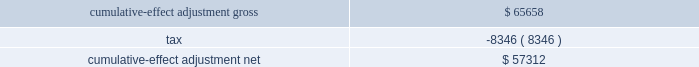Other-than-temporary impairments on investment securities .
In april 2009 , the fasb revised the authoritative guidance for the recognition and presentation of other-than-temporary impairments .
This new guidance amends the recognition guidance for other-than-temporary impairments of debt securities and expands the financial statement disclosures for other-than-temporary impairments on debt and equity securities .
For available for sale debt securities that the company has no intent to sell and more likely than not will not be required to sell prior to recovery , only the credit loss component of the impairment would be recognized in earnings , while the rest of the fair value loss would be recognized in accumulated other comprehensive income ( loss ) .
The company adopted this guidance effective april 1 , 2009 .
Upon adoption the company recognized a cumulative-effect adjustment increase in retained earnings ( deficit ) and decrease in accumulated other comprehensive income ( loss ) as follows : ( dollars in thousands ) .
Measurement of fair value in inactive markets .
In april 2009 , the fasb revised the authoritative guidance for fair value measurements and disclosures , which reaffirms that fair value is the price that would be received to sell an asset or paid to transfer a liability in an orderly transaction between market participants at the measurement date under current market conditions .
It also reaffirms the need to use judgment in determining if a formerly active market has become inactive and in determining fair values when the market has become inactive .
There was no impact to the company 2019s financial statements upon adoption .
Fair value disclosures about pension plan assets .
In december 2008 , the fasb revised the authoritative guidance for employers 2019 disclosures about pension plan assets .
This new guidance requires additional disclosures about the components of plan assets , investment strategies for plan assets and significant concentrations of risk within plan assets .
The company , in conjunction with fair value measurement of plan assets , separated plan assets into the three fair value hierarchy levels and provided a roll forward of the changes in fair value of plan assets classified as level 3 in the 2009 annual consolidated financial statements .
These disclosures had no effect on the company 2019s accounting for plan benefits and obligations .
Revisions to earnings per share calculation .
In june 2008 , the fasb revised the authoritative guidance for earnings per share for determining whether instruments granted in share-based payment transactions are participating securities .
This new guidance requires unvested share-based payment awards that contain non- forfeitable rights to dividends be considered as a separate class of common stock and included in the earnings per share calculation using the two-class method .
The company 2019s restricted share awards meet this definition and are therefore included in the basic earnings per share calculation .
Additional disclosures for derivative instruments .
In march 2008 , the fasb issued authoritative guidance for derivative instruments and hedging activities , which requires enhanced disclosures on derivative instruments and hedged items .
On january 1 , 2009 , the company adopted the additional disclosure for the equity index put options .
No comparative information for periods prior to the effective date was required .
This guidance had no impact on how the company records its derivatives. .
What percent of their cumulative-effect adjustment gross was tax? 
Rationale: 12.7%
Computations: (1 - (57312 / 65658))
Answer: 0.12711. 